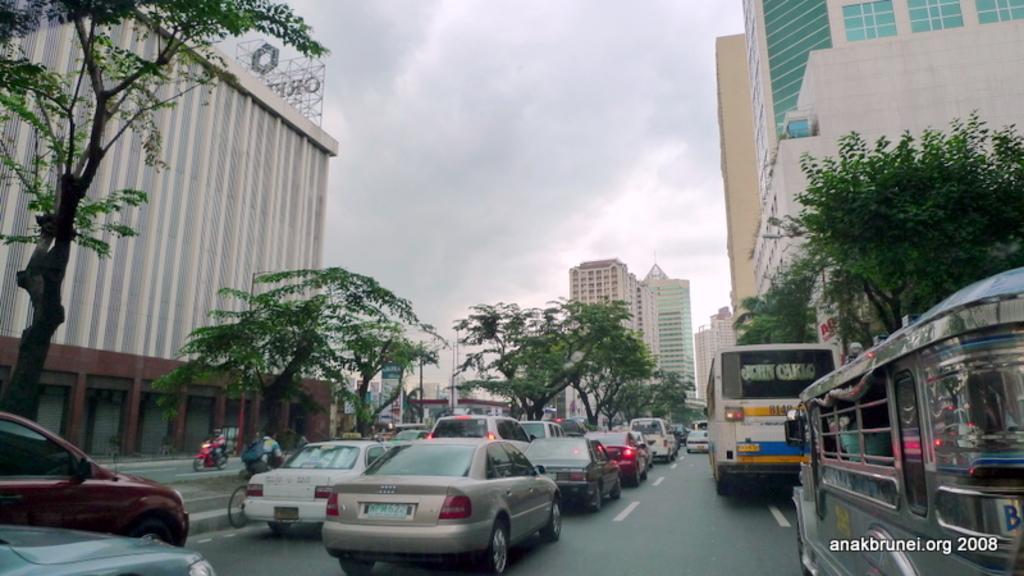Describe this image in one or two sentences. This picture shows few buildings and we see trees and few cars and a bus and we see a mini bus on the road and we see a man riding bicycle and we see a man moving on the motorcycle on the other side of the road and we see Hoardings and a cloudy sky and we see text at the bottom right corner. 